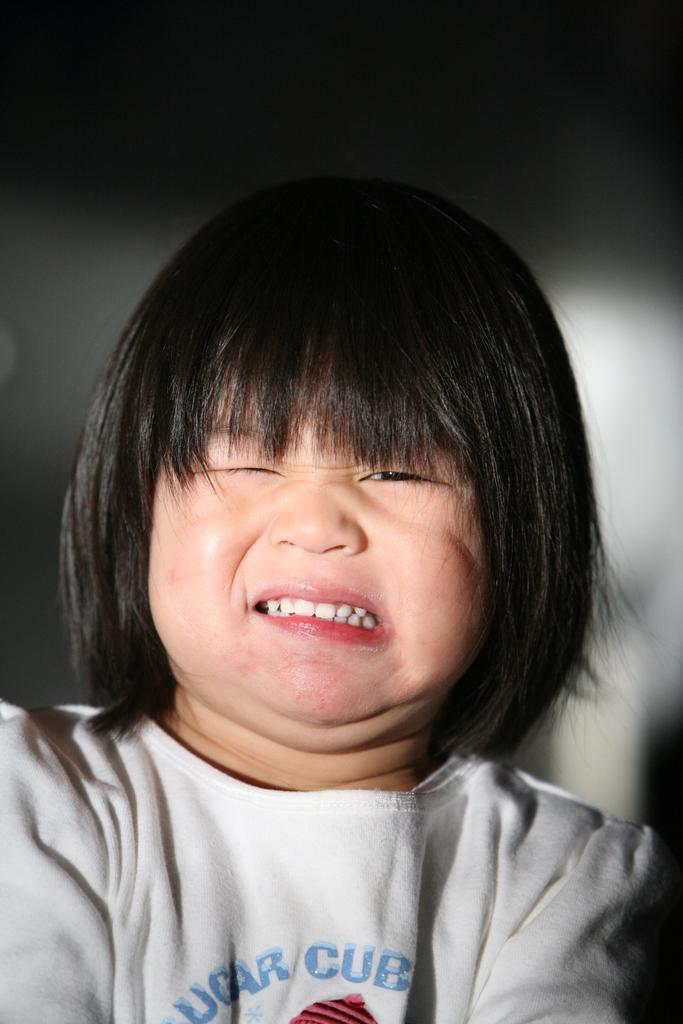What is the main subject of the image? The main subject of the image is a kid. What can be seen in the background of the image? There is a wall in the background of the image. How many deer are visible in the image? There are no deer present in the image. What type of print is the writer using in the image? There is no writer or print present in the image. 